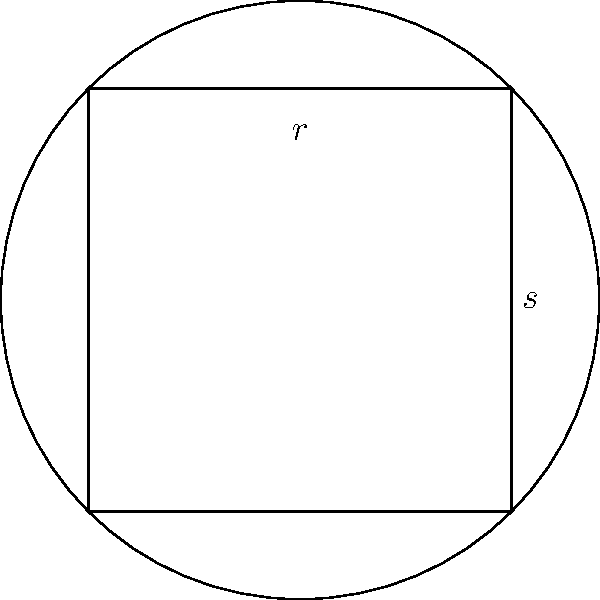You are designing a square floor space with side length $s$ for a traditional Indian rangoli pattern. To maximize the area of a circular rangoli within this square, what should be the radius $r$ of the circle, and what is the maximum area of the rangoli? Express your answer in terms of $s$. Let's approach this step-by-step:

1) The square has side length $s$, and we want to fit the largest possible circle inside it.

2) The diameter of the circle will be equal to the side length of the square. So, the radius $r$ will be half of the diagonal of the square.

3) We can find the diagonal using the Pythagorean theorem:
   $$\text{diagonal}^2 = s^2 + s^2 = 2s^2$$
   $$\text{diagonal} = s\sqrt{2}$$

4) The radius $r$ is half of this:
   $$r = \frac{s\sqrt{2}}{2} = \frac{s}{\sqrt{2}}$$

5) Now that we have the radius, we can calculate the area of the circle:
   $$A = \pi r^2 = \pi (\frac{s}{\sqrt{2}})^2 = \frac{\pi s^2}{2}$$

Therefore, the maximum radius of the circular rangoli is $\frac{s}{\sqrt{2}}$, and its maximum area is $\frac{\pi s^2}{2}$.
Answer: $r = \frac{s}{\sqrt{2}}$, $A = \frac{\pi s^2}{2}$ 